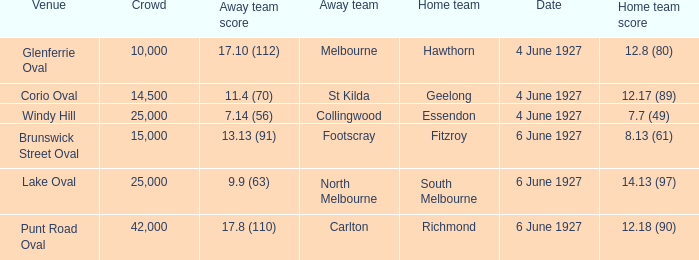Which team was at Corio Oval on 4 June 1927? St Kilda. 